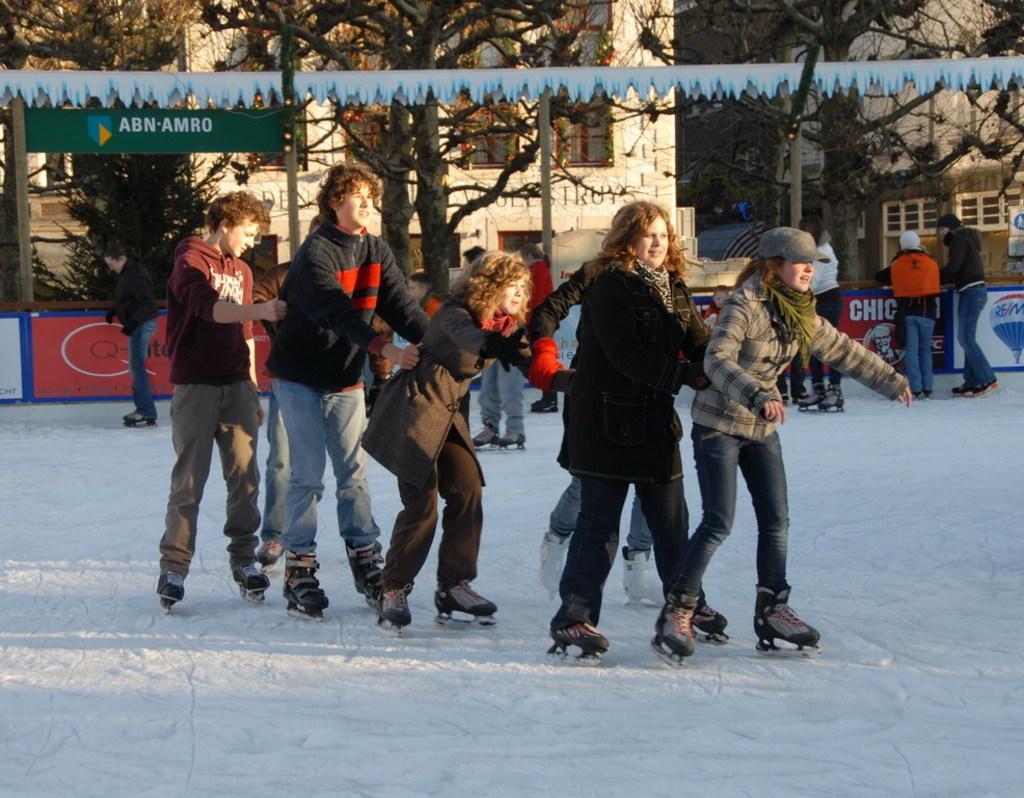In one or two sentences, can you explain what this image depicts? In the center of the picture there are people ice skating. At the foreground of the picture there is ice. In the background there are people skating. In the background there are trees, buildings, ribbons and banners. 